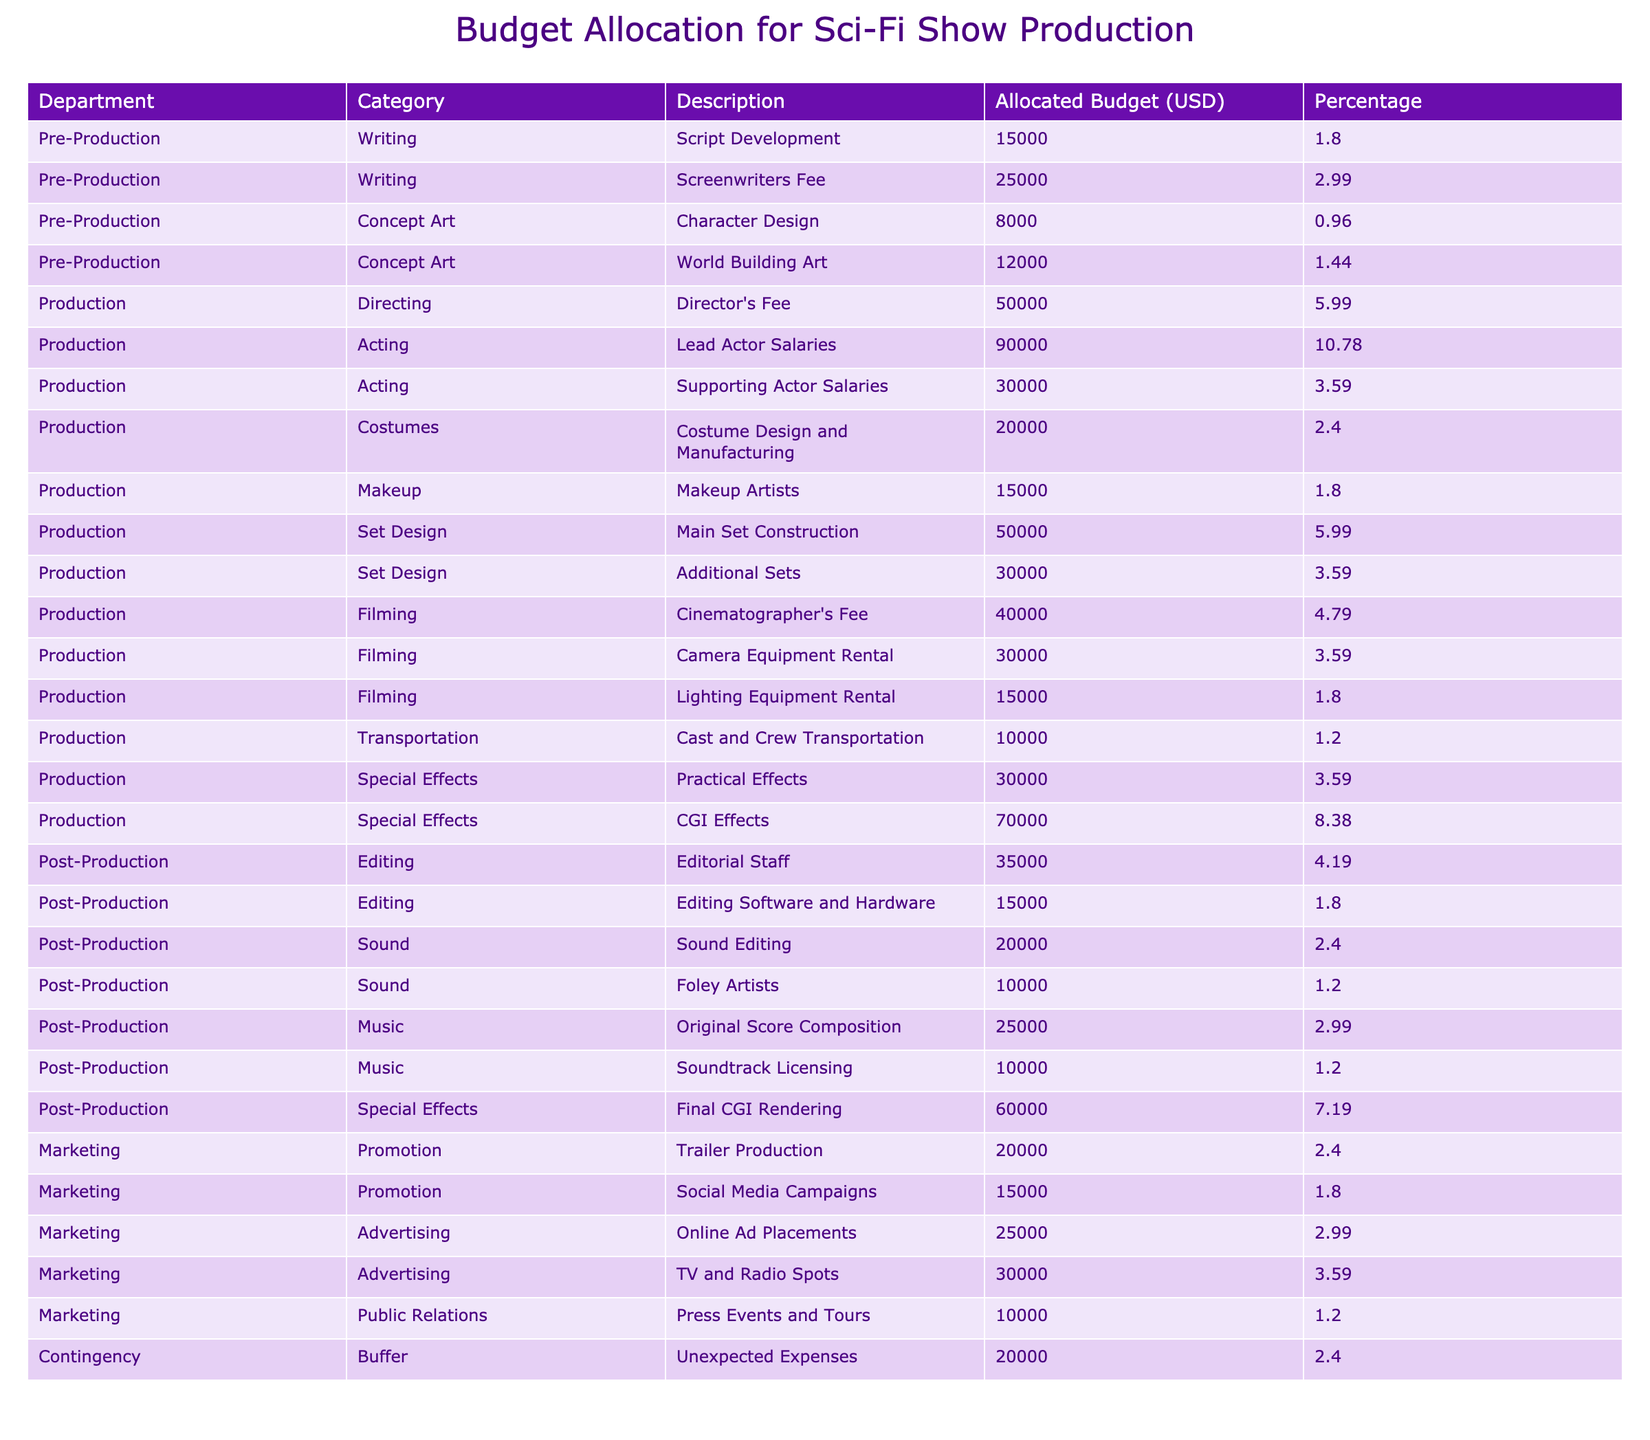What is the total budget allocated for Production? To find the total budget for the Production department, I need to sum all the allocated budgets listed under the Production section of the table. The values are: 50000 (Directing) + 90000 (Lead Actor Salaries) + 30000 (Supporting Actor Salaries) + 20000 (Costume Design and Manufacturing) + 15000 (Makeup Artists) + 50000 (Main Set Construction) + 30000 (Additional Sets) + 40000 (Cinematographer's Fee) + 30000 (Camera Equipment Rental) + 15000 (Lighting Equipment Rental) + 10000 (Transportation) + 30000 (Practical Effects) + 70000 (CGI Effects) =  420000.
Answer: 420000 Which category has the highest allocated budget? I need to compare the total budgets of each category within the table. By adding up the budgets for each category, I find: Writing: 40000, Concept Art: 20000, Directing: 50000, Acting: 120000, Costumes: 20000, Makeup: 15000, Set Design: 80000, Filming: 85000, Special Effects: 100000, Editing: 50000, Sound: 30000, Music: 35000, Promotion: 35000, Advertising: 55000, Public Relations: 10000, Buffer: 20000. The highest is Acting with 120000.
Answer: Acting Is the allocated budget for Sound Editing higher than that for Foley Artists? I will check the allocated budgets in the Sound category. For Sound Editing, the budget is 20000, while for Foley Artists, it is 10000. Since 20000 > 10000, the statement is true.
Answer: Yes What percentage of the total budget is allocated to Marketing? To find the percentage for Marketing, first, I need to sum the allocated budgets for the Marketing department: 20000 (Trailer Production) + 15000 (Social Media Campaigns) + 25000 (Online Ad Placements) + 30000 (TV and Radio Spots) + 10000 (Press Events and Tours) = 100000. Then, I divide this by the total budget of 570000 and multiply by 100: (100000 / 570000) * 100 = 17.54%.
Answer: 17.54 How much more is allocated to CGI Effects compared to Practical Effects? I find the budgets for both categories in the Special Effects section: CGI Effects has 70000 and Practical Effects has 30000. I then calculate the difference: 70000 - 30000 = 40000.
Answer: 40000 